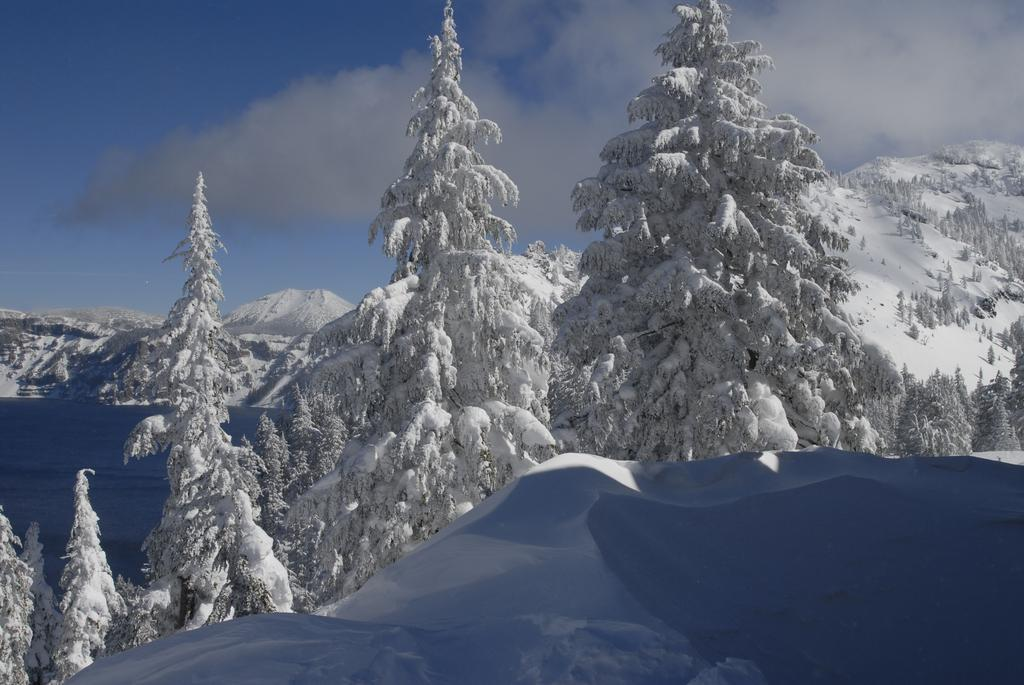What type of geographical feature is present in the image? There are mountains in the image. What is the condition of the mountains in the image? The mountains are covered with snow. What type of vegetation can be seen in the image? There are trees in the image. What is the condition of the trees in the image? The trees are covered with snow. What type of religious ceremony is taking place at the base of the mountain in the image? There is no indication of a religious ceremony or any people in the image; it only features snow-covered mountains and trees. 